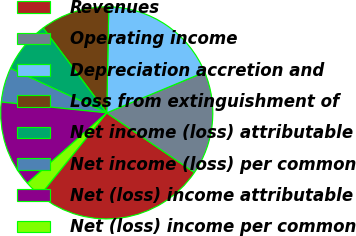Convert chart. <chart><loc_0><loc_0><loc_500><loc_500><pie_chart><fcel>Revenues<fcel>Operating income<fcel>Depreciation accretion and<fcel>Loss from extinguishment of<fcel>Net income (loss) attributable<fcel>Net income (loss) per common<fcel>Net (loss) income attributable<fcel>Net (loss) income per common<nl><fcel>26.32%<fcel>15.79%<fcel>18.42%<fcel>10.53%<fcel>7.89%<fcel>5.26%<fcel>13.16%<fcel>2.63%<nl></chart> 